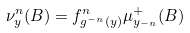Convert formula to latex. <formula><loc_0><loc_0><loc_500><loc_500>\nu _ { y } ^ { n } ( B ) & = f ^ { n } _ { g ^ { - n } ( y ) } \mu ^ { + } _ { y _ { - n } } ( B )</formula> 